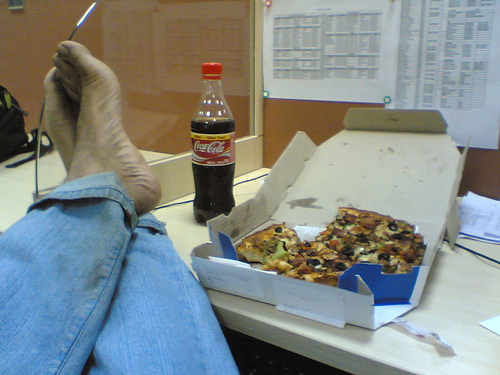<image>What room are these books in? I don't know exactly which room the books are in. They could be in an office, a dorm room, a den, or even a kitchen. What race is the man? I don't know what race the man is. It could be any race. What room are these books in? I am not sure what room these books are in. It can be seen in an office or a den. What race is the man? I don't know the race of the man. It can be Hispanic, white, Indian, black, Mexican, or something else. 